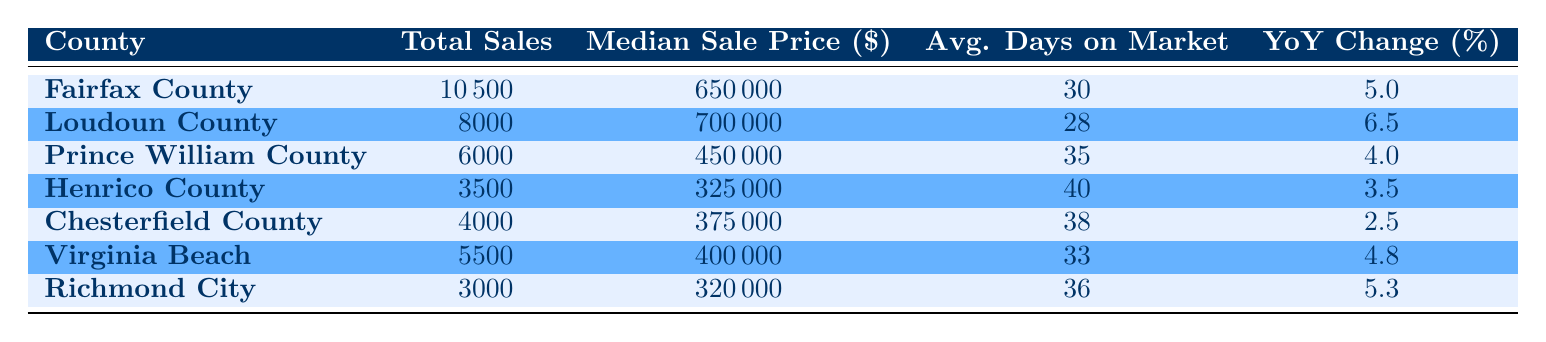What county has the highest total sales in Virginia for 2023? By examining the "Total Sales" column in the table, we can compare the values for each county. Fairfax County has the highest total sales listed at 10,500.
Answer: Fairfax County What is the median sale price in Loudoun County? Looking directly at the "Median Sale Price" column for Loudoun County, the value is 700,000.
Answer: 700000 Which county had a year-over-year change greater than 5%? To find this, we can check the "Sale Year Over Year Change" column for each county. Loudoun County (6.5%) and Richmond City (5.3%) both exceed 5%.
Answer: Loudoun County and Richmond City What is the average number of days on the market for properties sold in Virginia Beach and Chesterfield County combined? We first find the average number of days on the market for both counties: Virginia Beach has 33 days and Chesterfield County has 38 days. The sum is 33 + 38 = 71. We then divide by 2 for the average: 71 / 2 = 35.5.
Answer: 35.5 Is the median sale price in Prince William County higher than that in Chesterfield County? By checking the "Median Sale Price" column, we see that Prince William County is at 450,000 while Chesterfield County is at 375,000. Since 450,000 is greater than 375,000, the statement is true.
Answer: Yes What is the total number of sales across all counties listed in the table? We need to sum the "Total Sales" values for each county: 10,500 + 8,000 + 6,000 + 3,500 + 4,000 + 5,500 + 3,000 = 40,500.
Answer: 40500 Which county has the lowest average days on the market? Reviewing the "Average Days on Market" column, we can see that Loudoun County has the lowest value at 28 days.
Answer: Loudoun County Did any county experience a year-over-year change of less than 3%? Checking the "Sale Year Over Year Change" column reveals that Chesterfield County with 2.5% had a value below 3%.
Answer: Yes What is the difference in median sale price between Fairfax County and Richmond City? The median sale price for Fairfax County is 650,000, and for Richmond City, it is 320,000. We calculate the difference: 650,000 - 320,000 = 330,000.
Answer: 330000 